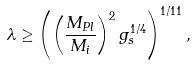Convert formula to latex. <formula><loc_0><loc_0><loc_500><loc_500>\lambda \geq \left ( \left ( \frac { M _ { P l } } { M _ { i } } \right ) ^ { 2 } g _ { s } ^ { 1 / 4 } \right ) ^ { 1 / 1 1 } ,</formula> 